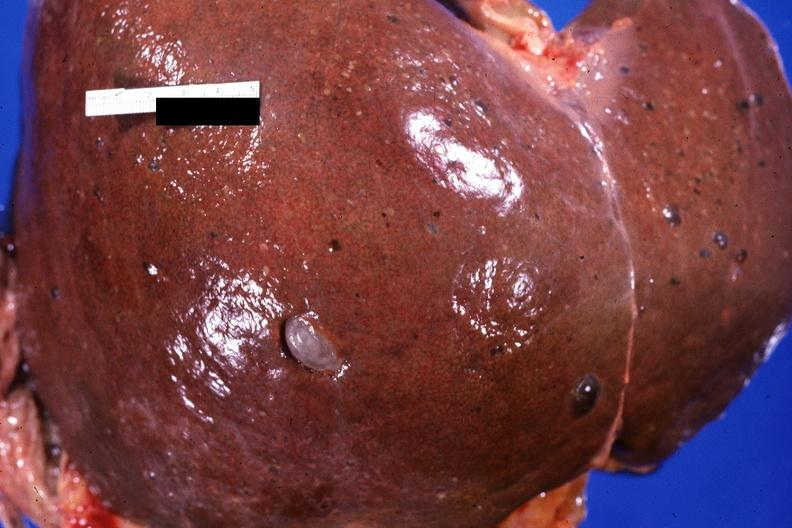what does this image show?
Answer the question using a single word or phrase. Liver 